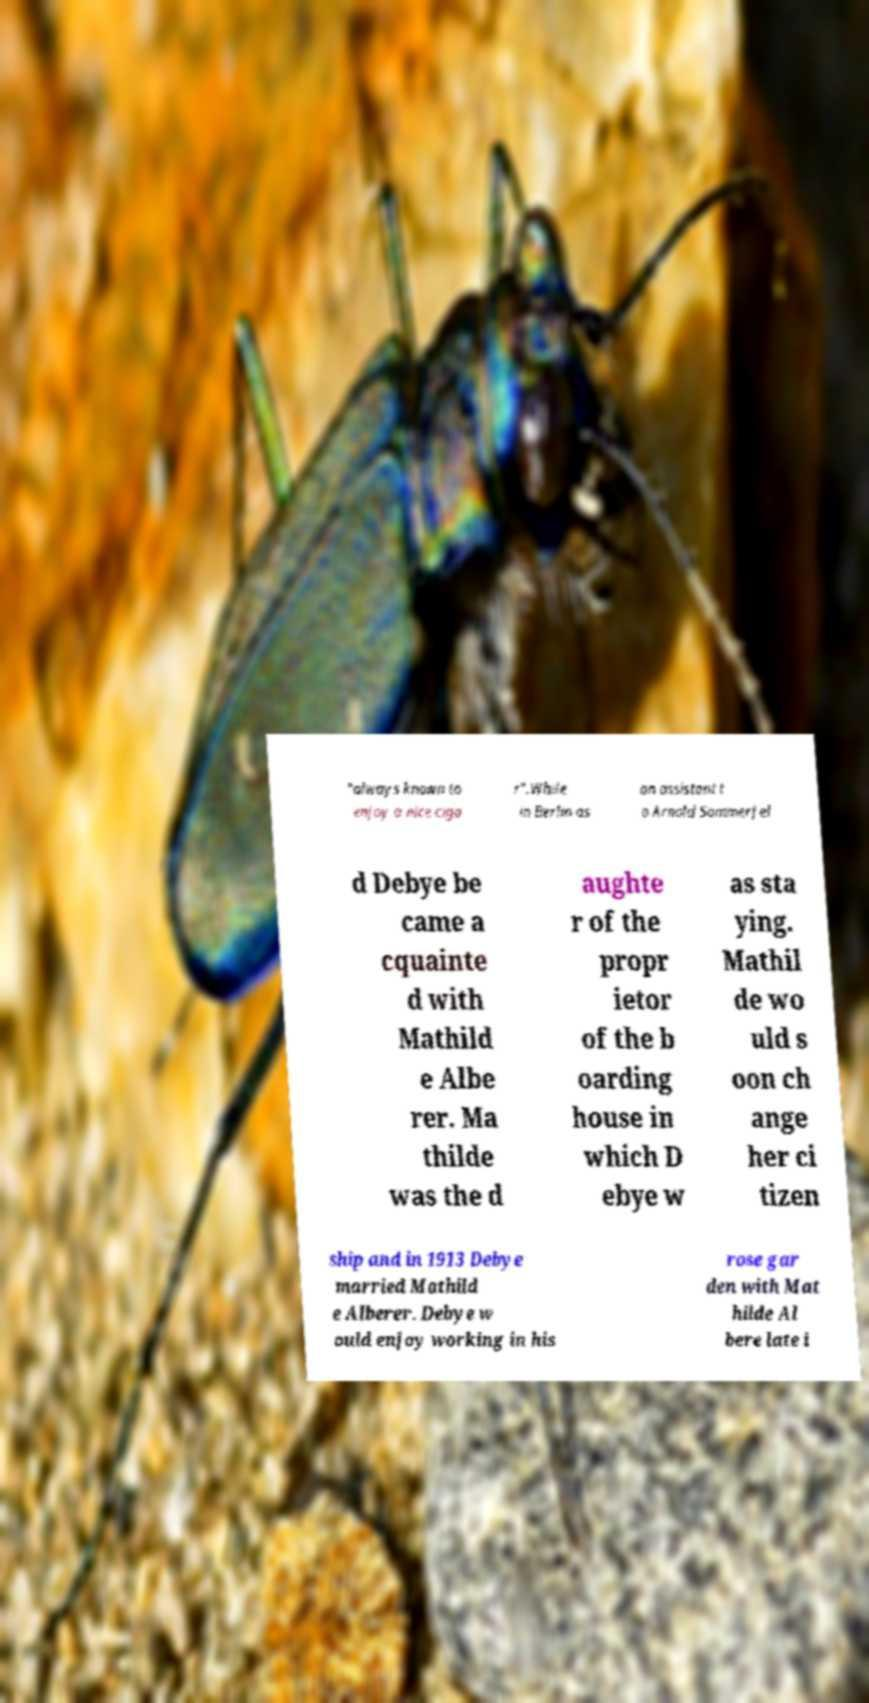What messages or text are displayed in this image? I need them in a readable, typed format. "always known to enjoy a nice ciga r".While in Berlin as an assistant t o Arnold Sommerfel d Debye be came a cquainte d with Mathild e Albe rer. Ma thilde was the d aughte r of the propr ietor of the b oarding house in which D ebye w as sta ying. Mathil de wo uld s oon ch ange her ci tizen ship and in 1913 Debye married Mathild e Alberer. Debye w ould enjoy working in his rose gar den with Mat hilde Al bere late i 